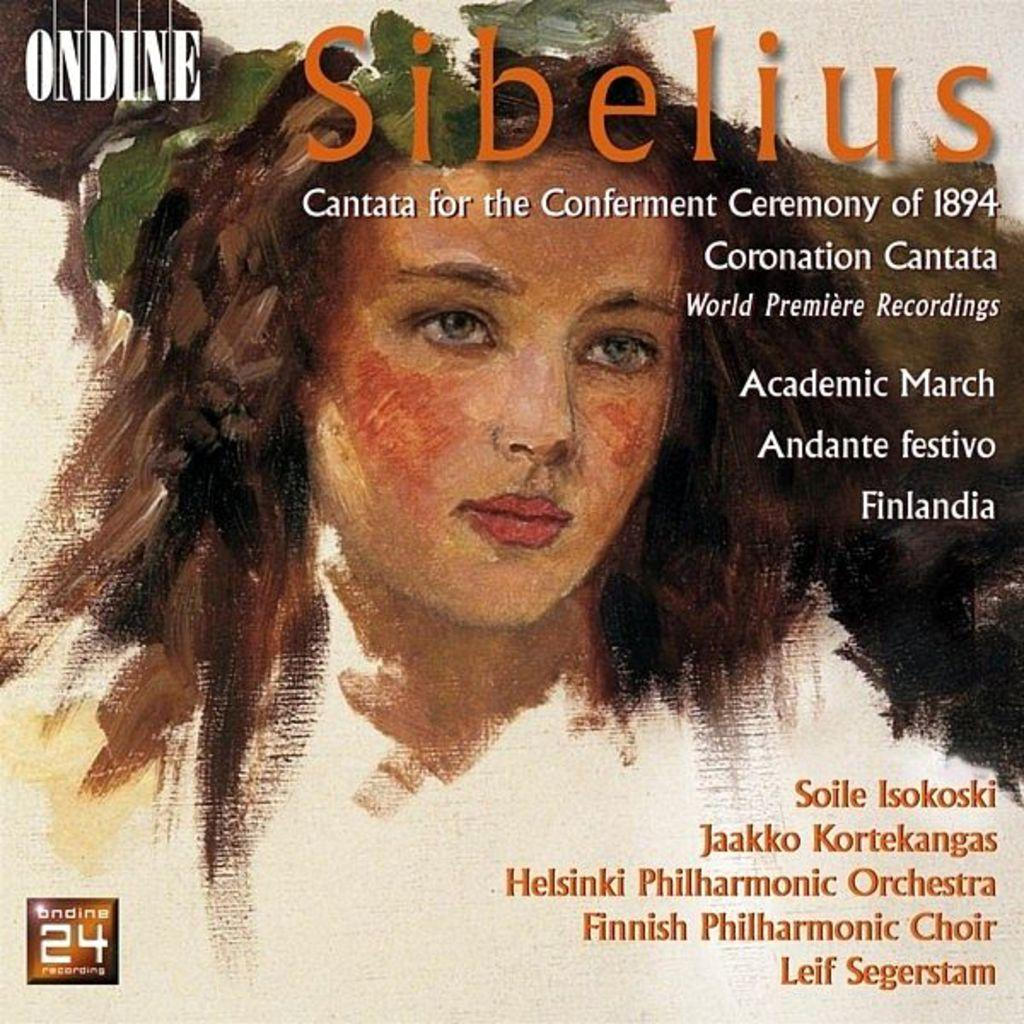What is featured on the poster in the image? The poster contains a painting of a person. What else can be found on the poster besides the painting? There is writing or matter on the poster. Is there an umbrella visible in the painting on the poster? There is no umbrella present in the painting on the poster. What type of cooking utensils can be seen in the painting on the poster? There are no cooking utensils present in the painting on the poster. 